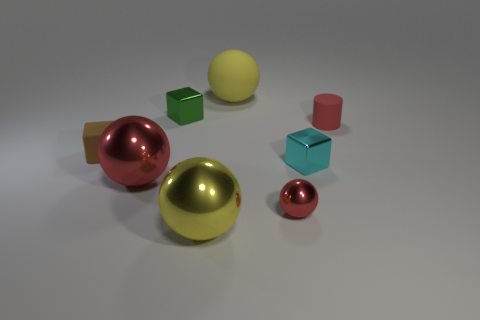Subtract all big red metallic spheres. How many spheres are left? 3 Subtract all green blocks. How many blocks are left? 2 Subtract 2 cubes. How many cubes are left? 1 Add 1 big yellow metallic objects. How many objects exist? 9 Subtract all cubes. How many objects are left? 5 Subtract all purple cubes. Subtract all yellow cylinders. How many cubes are left? 3 Subtract all green cylinders. How many blue blocks are left? 0 Subtract all red matte things. Subtract all brown matte cubes. How many objects are left? 6 Add 3 green cubes. How many green cubes are left? 4 Add 6 red balls. How many red balls exist? 8 